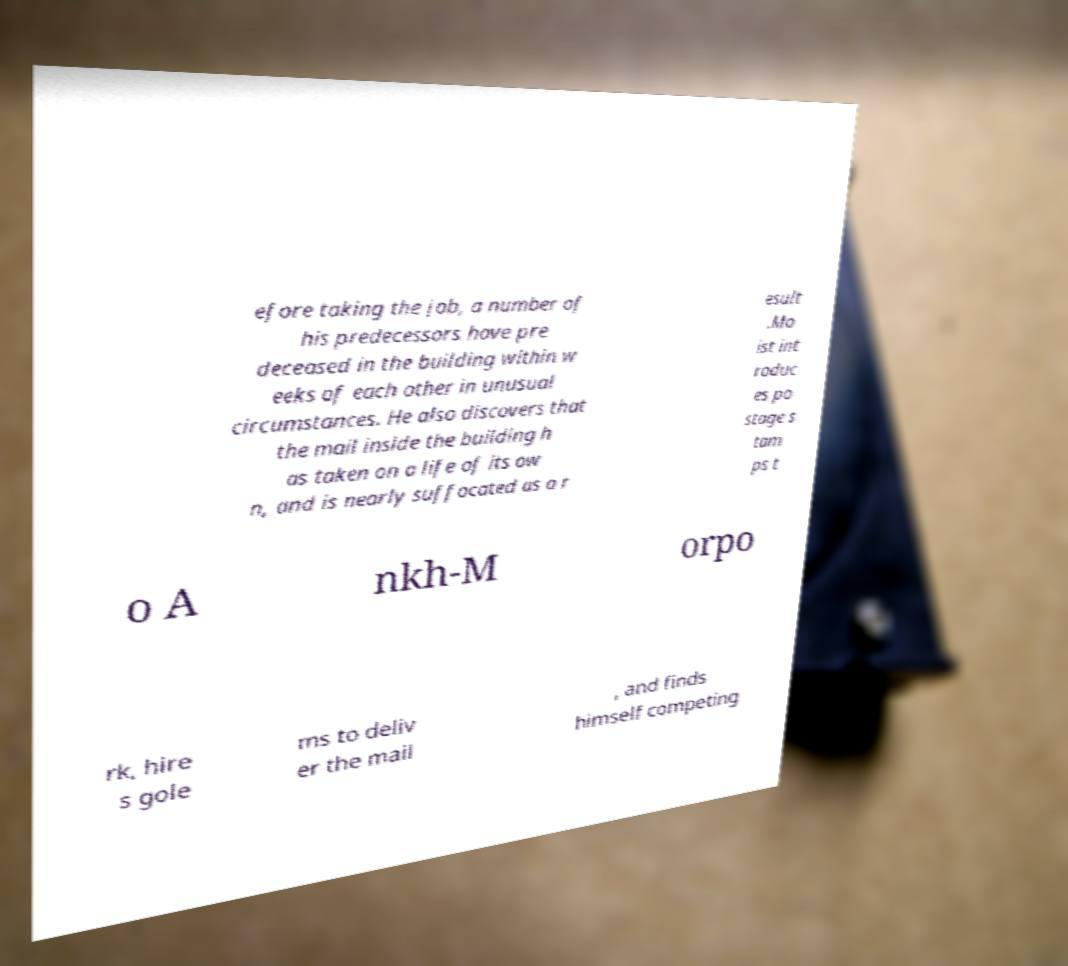Can you read and provide the text displayed in the image?This photo seems to have some interesting text. Can you extract and type it out for me? efore taking the job, a number of his predecessors have pre deceased in the building within w eeks of each other in unusual circumstances. He also discovers that the mail inside the building h as taken on a life of its ow n, and is nearly suffocated as a r esult .Mo ist int roduc es po stage s tam ps t o A nkh-M orpo rk, hire s gole ms to deliv er the mail , and finds himself competing 